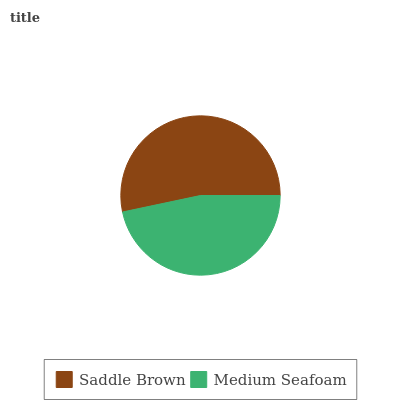Is Medium Seafoam the minimum?
Answer yes or no. Yes. Is Saddle Brown the maximum?
Answer yes or no. Yes. Is Medium Seafoam the maximum?
Answer yes or no. No. Is Saddle Brown greater than Medium Seafoam?
Answer yes or no. Yes. Is Medium Seafoam less than Saddle Brown?
Answer yes or no. Yes. Is Medium Seafoam greater than Saddle Brown?
Answer yes or no. No. Is Saddle Brown less than Medium Seafoam?
Answer yes or no. No. Is Saddle Brown the high median?
Answer yes or no. Yes. Is Medium Seafoam the low median?
Answer yes or no. Yes. Is Medium Seafoam the high median?
Answer yes or no. No. Is Saddle Brown the low median?
Answer yes or no. No. 